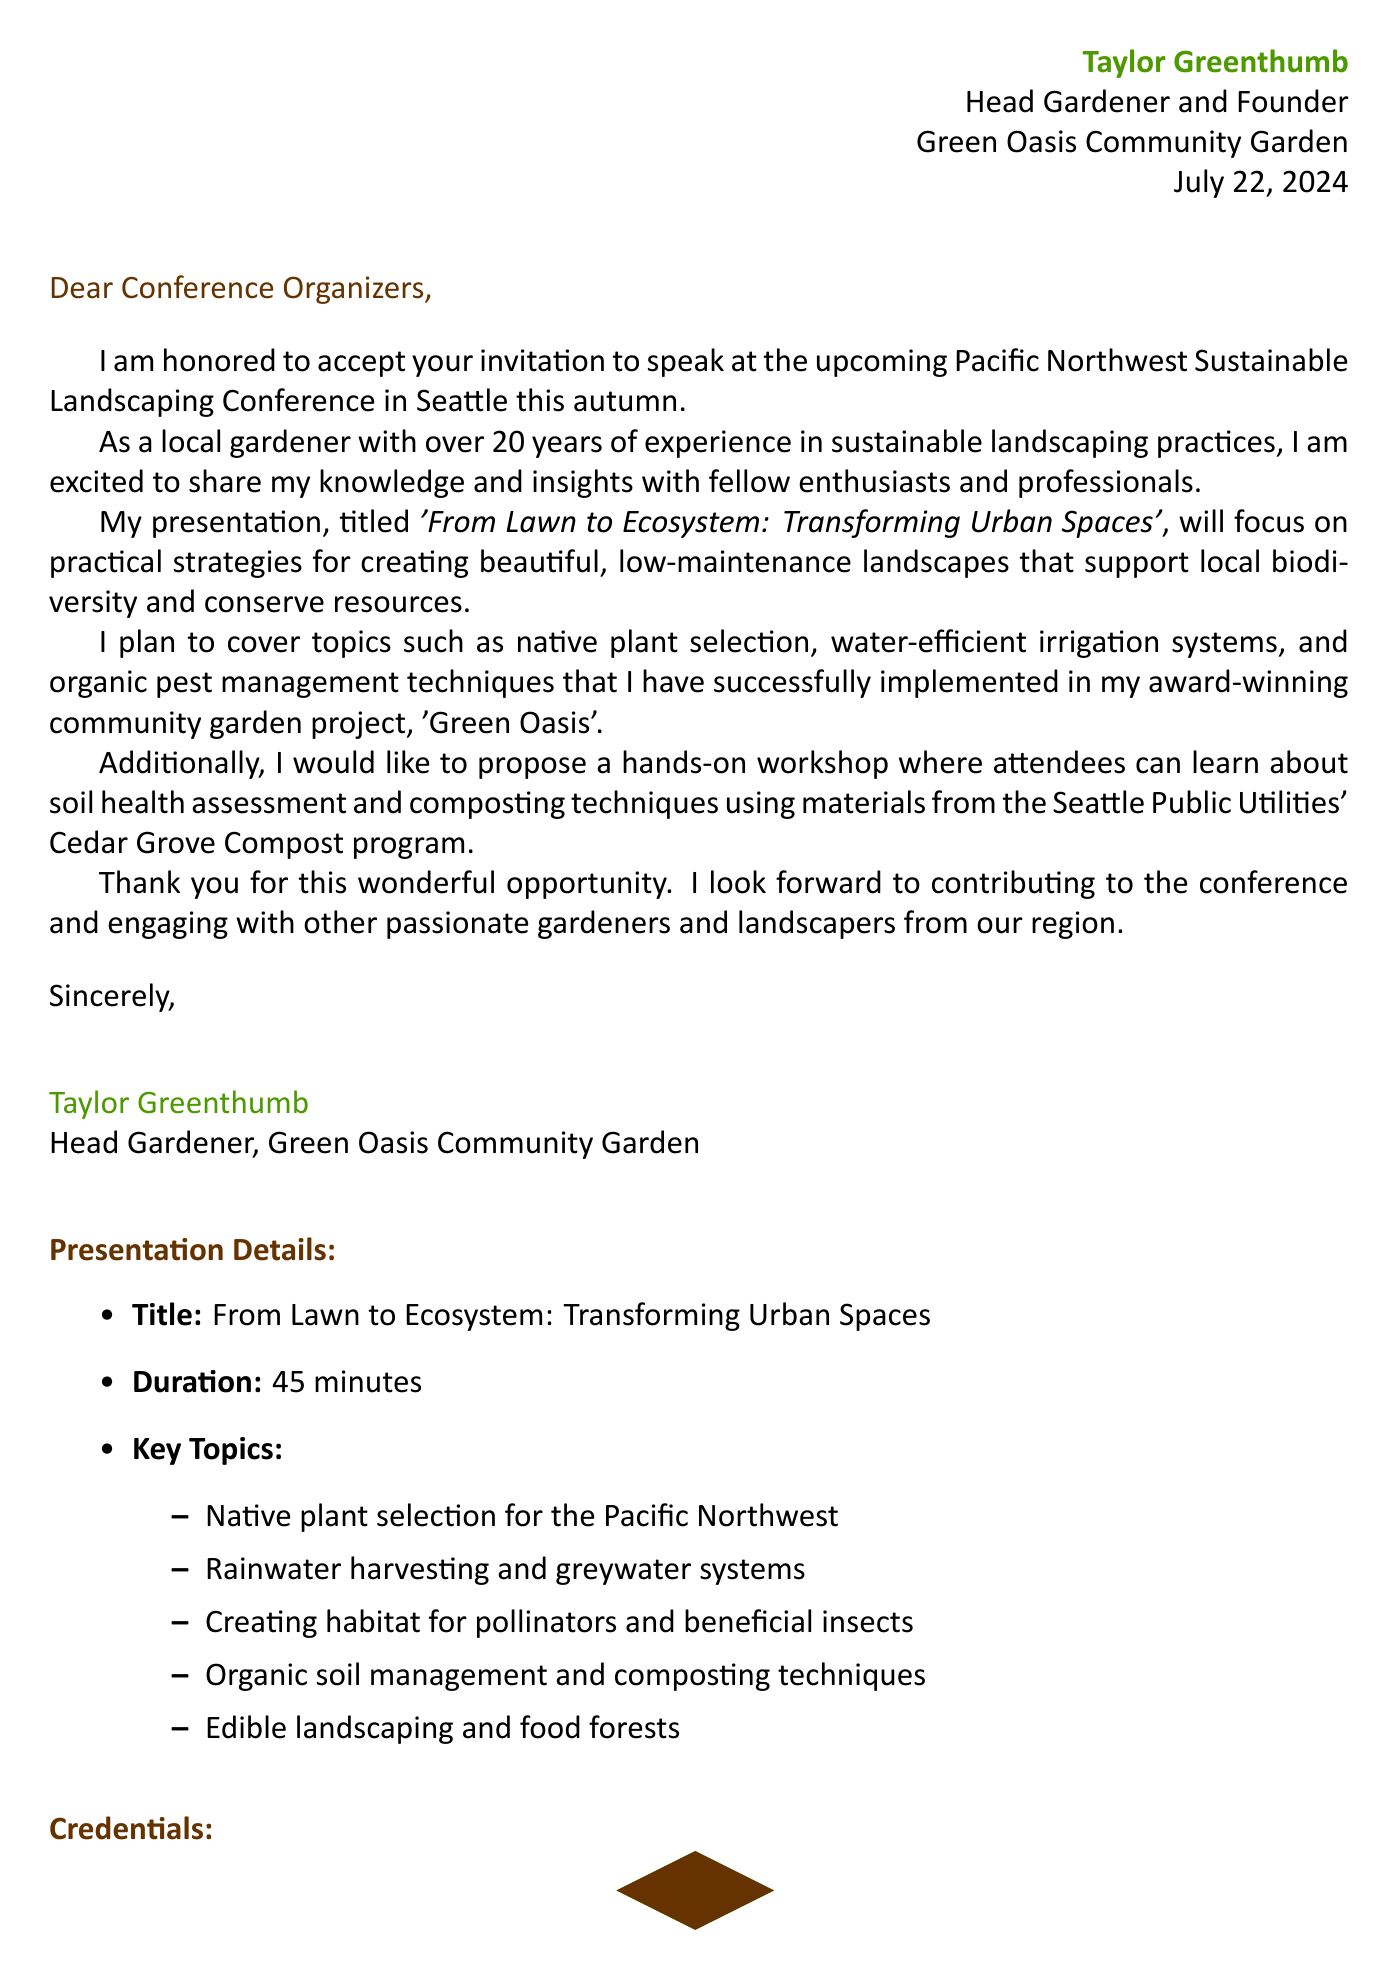What is the speaker's name? The speaker's name is stated at the beginning of the document, identified as Taylor Greenthumb.
Answer: Taylor Greenthumb What is the date of the conference? The date of the conference is included in the conference information section of the document.
Answer: October 15-17, 2023 What is the title of the presentation? The title of the presentation is specified in the body paragraphs of the letter.
Answer: From Lawn to Ecosystem: Transforming Urban Spaces How long will the presentation last? The duration of the presentation is mentioned in the presentation details section of the document.
Answer: 45 minutes What organization is hosting the conference? The hosting organization for the conference is noted in the conference information section.
Answer: Northwest Horticultural Society What is one key topic of the presentation? The key topics of the presentation are listed in the document, which includes practical aspects of sustainable landscaping.
Answer: Native plant selection for the Pacific Northwest Why does the speaker propose a workshop? The speaker suggests a workshop to offer practical, hands-on learning about soil health and composting based on document content.
Answer: Soil health assessment and composting techniques How many years of experience does the speaker have? The speaker's experience is explicitly mentioned in the opening paragraph of the letter.
Answer: 20 years 